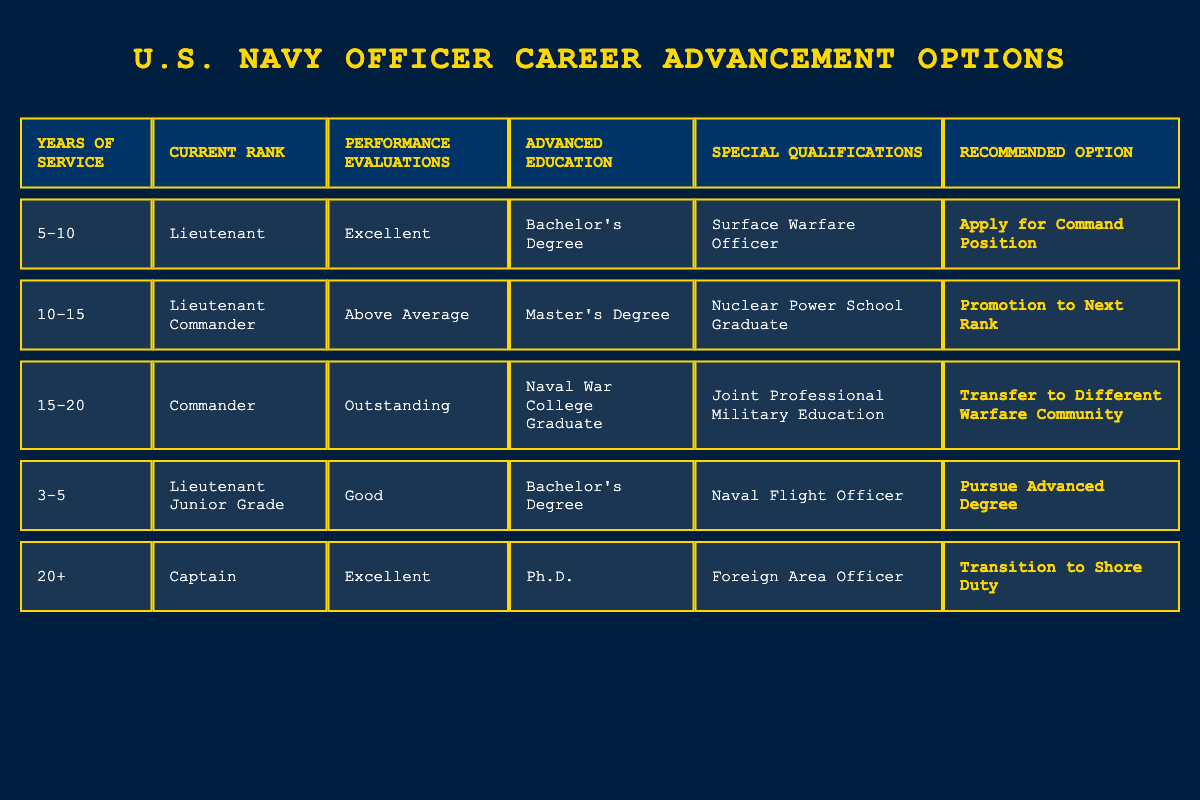What is the recommended option for an officer with 5-10 years of service? According to the table, for an officer with 5-10 years of service, currently holding the rank of Lieutenant and having excellent performance evaluations, the recommended option is "Apply for Command Position."
Answer: Apply for Command Position Is a Master’s Degree sufficient for promotion to the next rank if the officer is a Lieutenant Commander? Yes, the table indicates that a Lieutenant Commander with above-average performance evaluations and a Master’s Degree is recommended for promotion to the next rank.
Answer: Yes What qualifications do officers need to pursue an advanced degree? The table shows that a Lieutenant Junior Grade with 3-5 years of service, good performance evaluations, a Bachelor's Degree, and a qualification as a Naval Flight Officer is recommended to pursue an advanced degree.
Answer: Naval Flight Officer How many officers in the table are recommended to transfer to a different warfare community? There is one officer in the table recommended to transfer to a different warfare community, specifically a Commander with 15-20 years of service, outstanding performance evaluations, and qualifications in Joint Professional Military Education.
Answer: One officer Can you identify the average years of service for all recommended options? To find the average years of service, we sum the years of service for all recommended options (5-10, 10-15, 15-20, 3-5, 20+). This can be converted to numerical values (7.5, 12.5, 17.5, 4, 20). Then, we calculate the average: (7.5 + 12.5 + 17.5 + 4 + 20) / 5 = 12.5 years.
Answer: 12.5 years Is it true that an officer with 20+ years of service is recommended to apply for a command position? No, the table suggests that a Captain with 20+ years of service and excellent performance evaluations is recommended to transition to shore duty, not to apply for a command position.
Answer: No What special qualifications does the officer recommended to transition to shore duty have? The officer recommended to transition to shore duty after 20+ years of service and with a Ph.D. has the special qualification of being a Foreign Area Officer.
Answer: Foreign Area Officer 